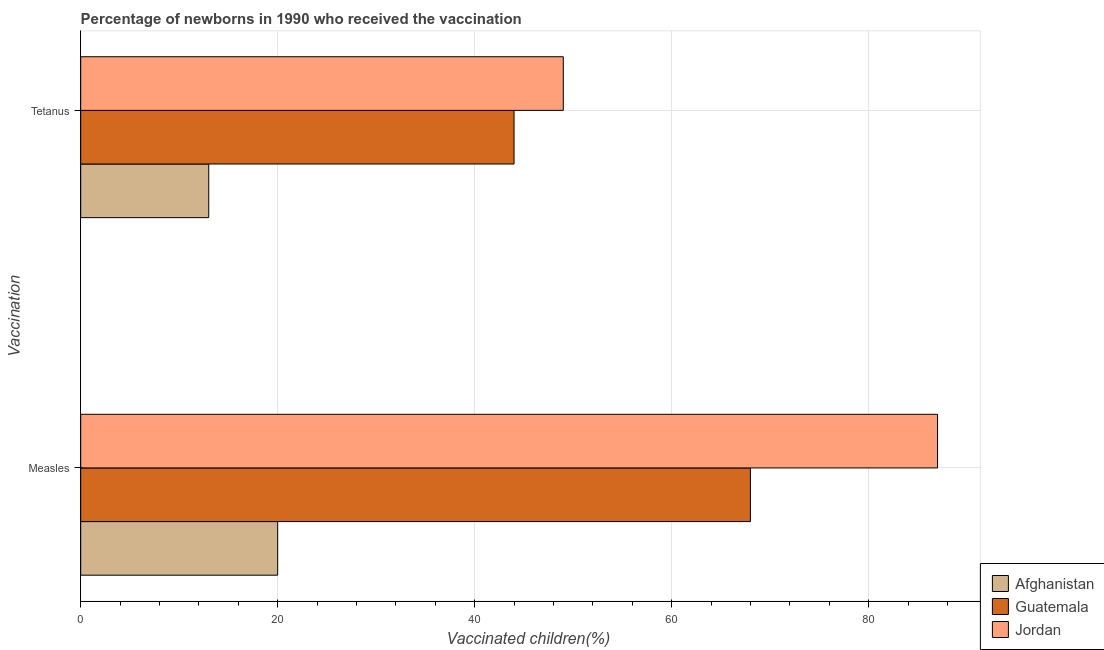How many different coloured bars are there?
Give a very brief answer. 3. How many groups of bars are there?
Offer a terse response. 2. Are the number of bars on each tick of the Y-axis equal?
Make the answer very short. Yes. How many bars are there on the 1st tick from the bottom?
Ensure brevity in your answer.  3. What is the label of the 2nd group of bars from the top?
Offer a very short reply. Measles. What is the percentage of newborns who received vaccination for tetanus in Afghanistan?
Your answer should be compact. 13. Across all countries, what is the maximum percentage of newborns who received vaccination for tetanus?
Make the answer very short. 49. Across all countries, what is the minimum percentage of newborns who received vaccination for tetanus?
Offer a very short reply. 13. In which country was the percentage of newborns who received vaccination for measles maximum?
Give a very brief answer. Jordan. In which country was the percentage of newborns who received vaccination for tetanus minimum?
Your response must be concise. Afghanistan. What is the total percentage of newborns who received vaccination for measles in the graph?
Make the answer very short. 175. What is the difference between the percentage of newborns who received vaccination for tetanus in Jordan and that in Guatemala?
Your answer should be very brief. 5. What is the difference between the percentage of newborns who received vaccination for measles in Afghanistan and the percentage of newborns who received vaccination for tetanus in Guatemala?
Your response must be concise. -24. What is the average percentage of newborns who received vaccination for tetanus per country?
Provide a short and direct response. 35.33. What is the difference between the percentage of newborns who received vaccination for measles and percentage of newborns who received vaccination for tetanus in Guatemala?
Keep it short and to the point. 24. What is the ratio of the percentage of newborns who received vaccination for measles in Guatemala to that in Jordan?
Ensure brevity in your answer.  0.78. What does the 2nd bar from the top in Measles represents?
Provide a short and direct response. Guatemala. What does the 1st bar from the bottom in Tetanus represents?
Make the answer very short. Afghanistan. How many bars are there?
Provide a short and direct response. 6. Are all the bars in the graph horizontal?
Keep it short and to the point. Yes. How many countries are there in the graph?
Your answer should be compact. 3. Are the values on the major ticks of X-axis written in scientific E-notation?
Make the answer very short. No. Does the graph contain grids?
Provide a succinct answer. Yes. Where does the legend appear in the graph?
Your answer should be compact. Bottom right. How many legend labels are there?
Give a very brief answer. 3. How are the legend labels stacked?
Provide a succinct answer. Vertical. What is the title of the graph?
Provide a short and direct response. Percentage of newborns in 1990 who received the vaccination. What is the label or title of the X-axis?
Offer a terse response. Vaccinated children(%)
. What is the label or title of the Y-axis?
Your answer should be compact. Vaccination. What is the Vaccinated children(%)
 in Guatemala in Measles?
Your answer should be compact. 68. Across all Vaccination, what is the maximum Vaccinated children(%)
 in Afghanistan?
Offer a very short reply. 20. Across all Vaccination, what is the minimum Vaccinated children(%)
 of Afghanistan?
Make the answer very short. 13. Across all Vaccination, what is the minimum Vaccinated children(%)
 in Guatemala?
Keep it short and to the point. 44. Across all Vaccination, what is the minimum Vaccinated children(%)
 in Jordan?
Your answer should be compact. 49. What is the total Vaccinated children(%)
 in Guatemala in the graph?
Make the answer very short. 112. What is the total Vaccinated children(%)
 in Jordan in the graph?
Ensure brevity in your answer.  136. What is the difference between the Vaccinated children(%)
 in Afghanistan in Measles and that in Tetanus?
Offer a terse response. 7. What is the difference between the Vaccinated children(%)
 of Guatemala in Measles and that in Tetanus?
Your answer should be compact. 24. What is the difference between the Vaccinated children(%)
 of Afghanistan in Measles and the Vaccinated children(%)
 of Guatemala in Tetanus?
Give a very brief answer. -24. What is the average Vaccinated children(%)
 of Afghanistan per Vaccination?
Ensure brevity in your answer.  16.5. What is the difference between the Vaccinated children(%)
 of Afghanistan and Vaccinated children(%)
 of Guatemala in Measles?
Give a very brief answer. -48. What is the difference between the Vaccinated children(%)
 in Afghanistan and Vaccinated children(%)
 in Jordan in Measles?
Offer a terse response. -67. What is the difference between the Vaccinated children(%)
 in Afghanistan and Vaccinated children(%)
 in Guatemala in Tetanus?
Your answer should be very brief. -31. What is the difference between the Vaccinated children(%)
 of Afghanistan and Vaccinated children(%)
 of Jordan in Tetanus?
Offer a very short reply. -36. What is the difference between the Vaccinated children(%)
 of Guatemala and Vaccinated children(%)
 of Jordan in Tetanus?
Provide a succinct answer. -5. What is the ratio of the Vaccinated children(%)
 in Afghanistan in Measles to that in Tetanus?
Your response must be concise. 1.54. What is the ratio of the Vaccinated children(%)
 in Guatemala in Measles to that in Tetanus?
Provide a succinct answer. 1.55. What is the ratio of the Vaccinated children(%)
 in Jordan in Measles to that in Tetanus?
Give a very brief answer. 1.78. What is the difference between the highest and the second highest Vaccinated children(%)
 of Jordan?
Provide a short and direct response. 38. What is the difference between the highest and the lowest Vaccinated children(%)
 in Afghanistan?
Keep it short and to the point. 7. What is the difference between the highest and the lowest Vaccinated children(%)
 of Guatemala?
Make the answer very short. 24. 